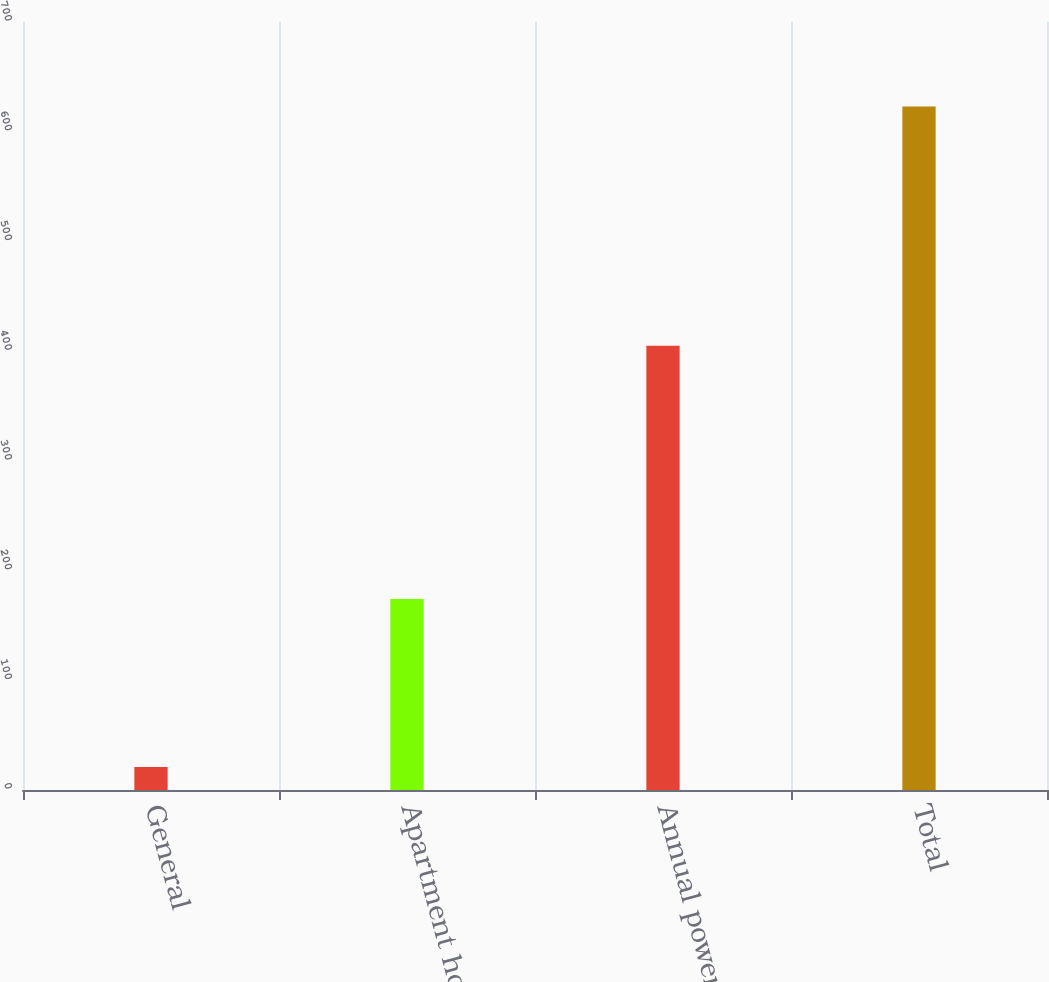Convert chart. <chart><loc_0><loc_0><loc_500><loc_500><bar_chart><fcel>General<fcel>Apartment house<fcel>Annual power<fcel>Total<nl><fcel>21<fcel>174<fcel>405<fcel>623<nl></chart> 